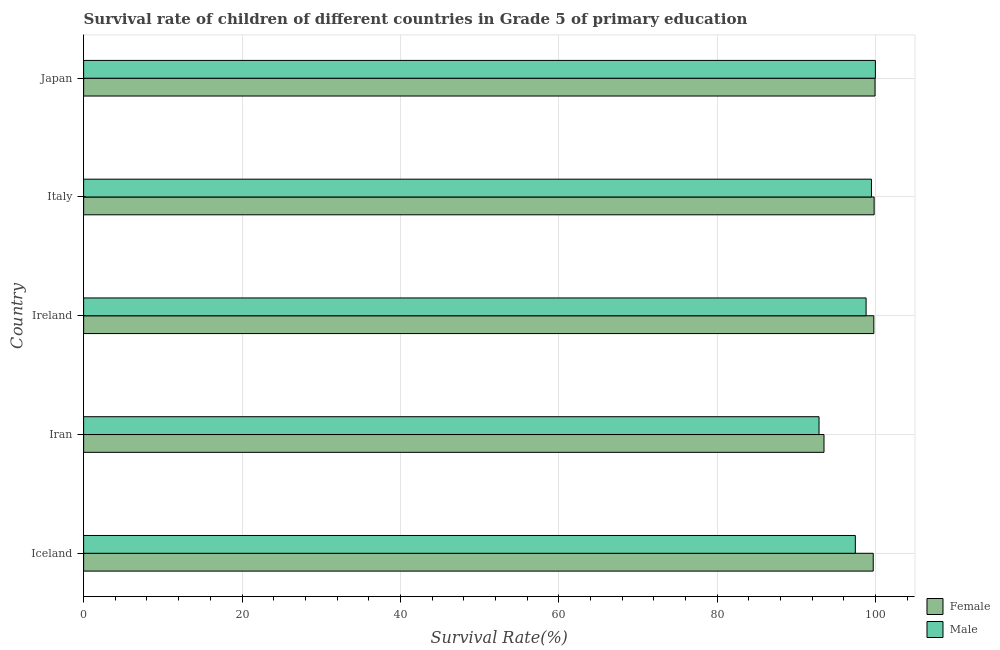Are the number of bars on each tick of the Y-axis equal?
Your answer should be compact. Yes. How many bars are there on the 2nd tick from the bottom?
Ensure brevity in your answer.  2. What is the label of the 4th group of bars from the top?
Ensure brevity in your answer.  Iran. In how many cases, is the number of bars for a given country not equal to the number of legend labels?
Your response must be concise. 0. What is the survival rate of male students in primary education in Iceland?
Your response must be concise. 97.44. Across all countries, what is the maximum survival rate of male students in primary education?
Your response must be concise. 99.97. Across all countries, what is the minimum survival rate of female students in primary education?
Offer a very short reply. 93.49. In which country was the survival rate of female students in primary education maximum?
Make the answer very short. Japan. In which country was the survival rate of female students in primary education minimum?
Provide a short and direct response. Iran. What is the total survival rate of male students in primary education in the graph?
Your answer should be compact. 488.56. What is the difference between the survival rate of male students in primary education in Iceland and that in Iran?
Provide a short and direct response. 4.58. What is the difference between the survival rate of female students in primary education in Iran and the survival rate of male students in primary education in Ireland?
Ensure brevity in your answer.  -5.32. What is the average survival rate of male students in primary education per country?
Ensure brevity in your answer.  97.71. What is the difference between the survival rate of female students in primary education and survival rate of male students in primary education in Iran?
Give a very brief answer. 0.63. In how many countries, is the survival rate of male students in primary education greater than 20 %?
Provide a short and direct response. 5. What is the ratio of the survival rate of female students in primary education in Iran to that in Japan?
Your answer should be very brief. 0.94. Is the survival rate of male students in primary education in Iran less than that in Italy?
Offer a terse response. Yes. Is the difference between the survival rate of female students in primary education in Ireland and Japan greater than the difference between the survival rate of male students in primary education in Ireland and Japan?
Keep it short and to the point. Yes. What is the difference between the highest and the second highest survival rate of male students in primary education?
Your answer should be very brief. 0.5. What is the difference between the highest and the lowest survival rate of male students in primary education?
Ensure brevity in your answer.  7.12. In how many countries, is the survival rate of male students in primary education greater than the average survival rate of male students in primary education taken over all countries?
Give a very brief answer. 3. Is the sum of the survival rate of female students in primary education in Iceland and Iran greater than the maximum survival rate of male students in primary education across all countries?
Give a very brief answer. Yes. What is the difference between two consecutive major ticks on the X-axis?
Your response must be concise. 20. Are the values on the major ticks of X-axis written in scientific E-notation?
Provide a succinct answer. No. Does the graph contain any zero values?
Provide a succinct answer. No. Does the graph contain grids?
Your answer should be compact. Yes. What is the title of the graph?
Your answer should be compact. Survival rate of children of different countries in Grade 5 of primary education. What is the label or title of the X-axis?
Your answer should be very brief. Survival Rate(%). What is the Survival Rate(%) of Female in Iceland?
Provide a succinct answer. 99.7. What is the Survival Rate(%) of Male in Iceland?
Offer a terse response. 97.44. What is the Survival Rate(%) in Female in Iran?
Give a very brief answer. 93.49. What is the Survival Rate(%) of Male in Iran?
Your response must be concise. 92.86. What is the Survival Rate(%) in Female in Ireland?
Your answer should be very brief. 99.78. What is the Survival Rate(%) in Male in Ireland?
Offer a very short reply. 98.8. What is the Survival Rate(%) in Female in Italy?
Your response must be concise. 99.82. What is the Survival Rate(%) in Male in Italy?
Your answer should be compact. 99.48. What is the Survival Rate(%) in Female in Japan?
Offer a very short reply. 99.93. What is the Survival Rate(%) in Male in Japan?
Provide a short and direct response. 99.97. Across all countries, what is the maximum Survival Rate(%) in Female?
Your response must be concise. 99.93. Across all countries, what is the maximum Survival Rate(%) in Male?
Provide a succinct answer. 99.97. Across all countries, what is the minimum Survival Rate(%) in Female?
Your response must be concise. 93.49. Across all countries, what is the minimum Survival Rate(%) in Male?
Give a very brief answer. 92.86. What is the total Survival Rate(%) of Female in the graph?
Offer a terse response. 492.71. What is the total Survival Rate(%) in Male in the graph?
Your response must be concise. 488.56. What is the difference between the Survival Rate(%) of Female in Iceland and that in Iran?
Make the answer very short. 6.22. What is the difference between the Survival Rate(%) of Male in Iceland and that in Iran?
Your answer should be very brief. 4.58. What is the difference between the Survival Rate(%) in Female in Iceland and that in Ireland?
Your answer should be compact. -0.08. What is the difference between the Survival Rate(%) of Male in Iceland and that in Ireland?
Provide a succinct answer. -1.36. What is the difference between the Survival Rate(%) in Female in Iceland and that in Italy?
Keep it short and to the point. -0.12. What is the difference between the Survival Rate(%) in Male in Iceland and that in Italy?
Provide a succinct answer. -2.03. What is the difference between the Survival Rate(%) of Female in Iceland and that in Japan?
Ensure brevity in your answer.  -0.23. What is the difference between the Survival Rate(%) of Male in Iceland and that in Japan?
Give a very brief answer. -2.53. What is the difference between the Survival Rate(%) in Female in Iran and that in Ireland?
Offer a very short reply. -6.29. What is the difference between the Survival Rate(%) of Male in Iran and that in Ireland?
Your response must be concise. -5.94. What is the difference between the Survival Rate(%) in Female in Iran and that in Italy?
Give a very brief answer. -6.33. What is the difference between the Survival Rate(%) in Male in Iran and that in Italy?
Ensure brevity in your answer.  -6.62. What is the difference between the Survival Rate(%) of Female in Iran and that in Japan?
Provide a succinct answer. -6.45. What is the difference between the Survival Rate(%) of Male in Iran and that in Japan?
Provide a succinct answer. -7.12. What is the difference between the Survival Rate(%) of Female in Ireland and that in Italy?
Provide a short and direct response. -0.04. What is the difference between the Survival Rate(%) in Male in Ireland and that in Italy?
Offer a terse response. -0.68. What is the difference between the Survival Rate(%) of Female in Ireland and that in Japan?
Provide a short and direct response. -0.15. What is the difference between the Survival Rate(%) in Male in Ireland and that in Japan?
Give a very brief answer. -1.17. What is the difference between the Survival Rate(%) of Female in Italy and that in Japan?
Keep it short and to the point. -0.11. What is the difference between the Survival Rate(%) of Male in Italy and that in Japan?
Provide a succinct answer. -0.5. What is the difference between the Survival Rate(%) of Female in Iceland and the Survival Rate(%) of Male in Iran?
Your response must be concise. 6.84. What is the difference between the Survival Rate(%) in Female in Iceland and the Survival Rate(%) in Male in Ireland?
Ensure brevity in your answer.  0.9. What is the difference between the Survival Rate(%) of Female in Iceland and the Survival Rate(%) of Male in Italy?
Your answer should be very brief. 0.22. What is the difference between the Survival Rate(%) of Female in Iceland and the Survival Rate(%) of Male in Japan?
Offer a very short reply. -0.27. What is the difference between the Survival Rate(%) of Female in Iran and the Survival Rate(%) of Male in Ireland?
Offer a terse response. -5.32. What is the difference between the Survival Rate(%) of Female in Iran and the Survival Rate(%) of Male in Italy?
Provide a short and direct response. -5.99. What is the difference between the Survival Rate(%) of Female in Iran and the Survival Rate(%) of Male in Japan?
Give a very brief answer. -6.49. What is the difference between the Survival Rate(%) of Female in Ireland and the Survival Rate(%) of Male in Italy?
Give a very brief answer. 0.3. What is the difference between the Survival Rate(%) of Female in Ireland and the Survival Rate(%) of Male in Japan?
Provide a short and direct response. -0.2. What is the difference between the Survival Rate(%) of Female in Italy and the Survival Rate(%) of Male in Japan?
Your answer should be very brief. -0.16. What is the average Survival Rate(%) of Female per country?
Your answer should be very brief. 98.54. What is the average Survival Rate(%) of Male per country?
Provide a short and direct response. 97.71. What is the difference between the Survival Rate(%) of Female and Survival Rate(%) of Male in Iceland?
Provide a succinct answer. 2.26. What is the difference between the Survival Rate(%) in Female and Survival Rate(%) in Male in Iran?
Your response must be concise. 0.63. What is the difference between the Survival Rate(%) of Female and Survival Rate(%) of Male in Ireland?
Offer a very short reply. 0.98. What is the difference between the Survival Rate(%) of Female and Survival Rate(%) of Male in Italy?
Keep it short and to the point. 0.34. What is the difference between the Survival Rate(%) in Female and Survival Rate(%) in Male in Japan?
Keep it short and to the point. -0.04. What is the ratio of the Survival Rate(%) of Female in Iceland to that in Iran?
Offer a very short reply. 1.07. What is the ratio of the Survival Rate(%) in Male in Iceland to that in Iran?
Keep it short and to the point. 1.05. What is the ratio of the Survival Rate(%) of Male in Iceland to that in Ireland?
Your response must be concise. 0.99. What is the ratio of the Survival Rate(%) in Male in Iceland to that in Italy?
Offer a terse response. 0.98. What is the ratio of the Survival Rate(%) in Male in Iceland to that in Japan?
Provide a succinct answer. 0.97. What is the ratio of the Survival Rate(%) in Female in Iran to that in Ireland?
Ensure brevity in your answer.  0.94. What is the ratio of the Survival Rate(%) in Male in Iran to that in Ireland?
Your answer should be compact. 0.94. What is the ratio of the Survival Rate(%) in Female in Iran to that in Italy?
Offer a very short reply. 0.94. What is the ratio of the Survival Rate(%) of Male in Iran to that in Italy?
Your answer should be compact. 0.93. What is the ratio of the Survival Rate(%) of Female in Iran to that in Japan?
Keep it short and to the point. 0.94. What is the ratio of the Survival Rate(%) of Male in Iran to that in Japan?
Offer a terse response. 0.93. What is the ratio of the Survival Rate(%) in Female in Ireland to that in Italy?
Give a very brief answer. 1. What is the ratio of the Survival Rate(%) of Male in Ireland to that in Japan?
Offer a terse response. 0.99. What is the ratio of the Survival Rate(%) in Female in Italy to that in Japan?
Give a very brief answer. 1. What is the difference between the highest and the second highest Survival Rate(%) in Female?
Your answer should be compact. 0.11. What is the difference between the highest and the second highest Survival Rate(%) in Male?
Offer a terse response. 0.5. What is the difference between the highest and the lowest Survival Rate(%) in Female?
Give a very brief answer. 6.45. What is the difference between the highest and the lowest Survival Rate(%) in Male?
Provide a short and direct response. 7.12. 